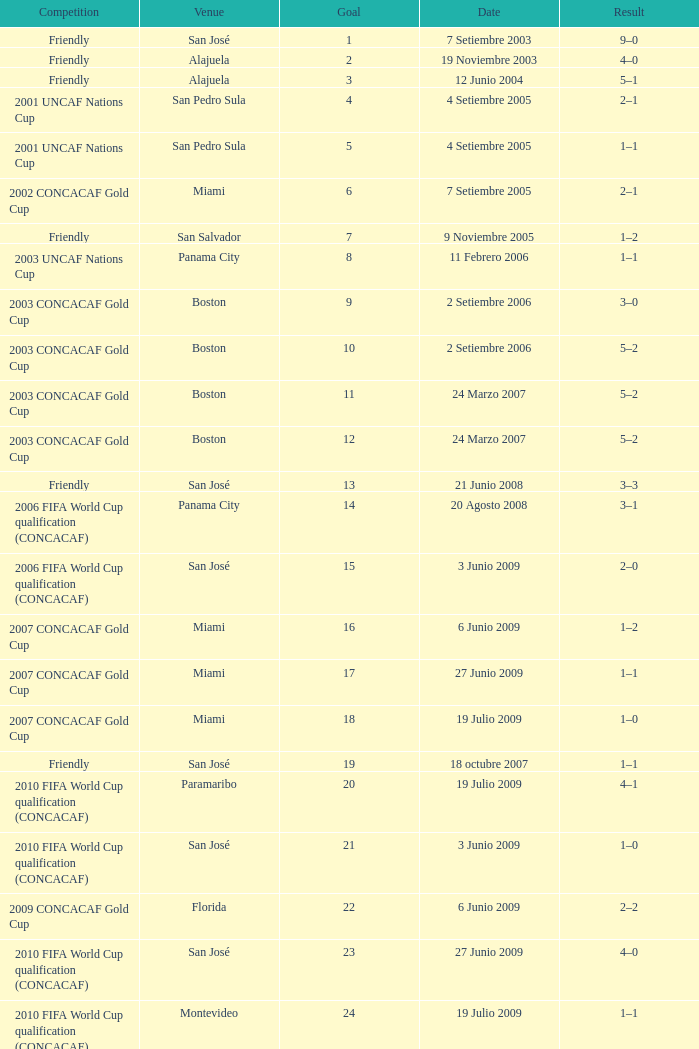At the venue of panama city, on 11 Febrero 2006, how many goals were scored? 1.0. 